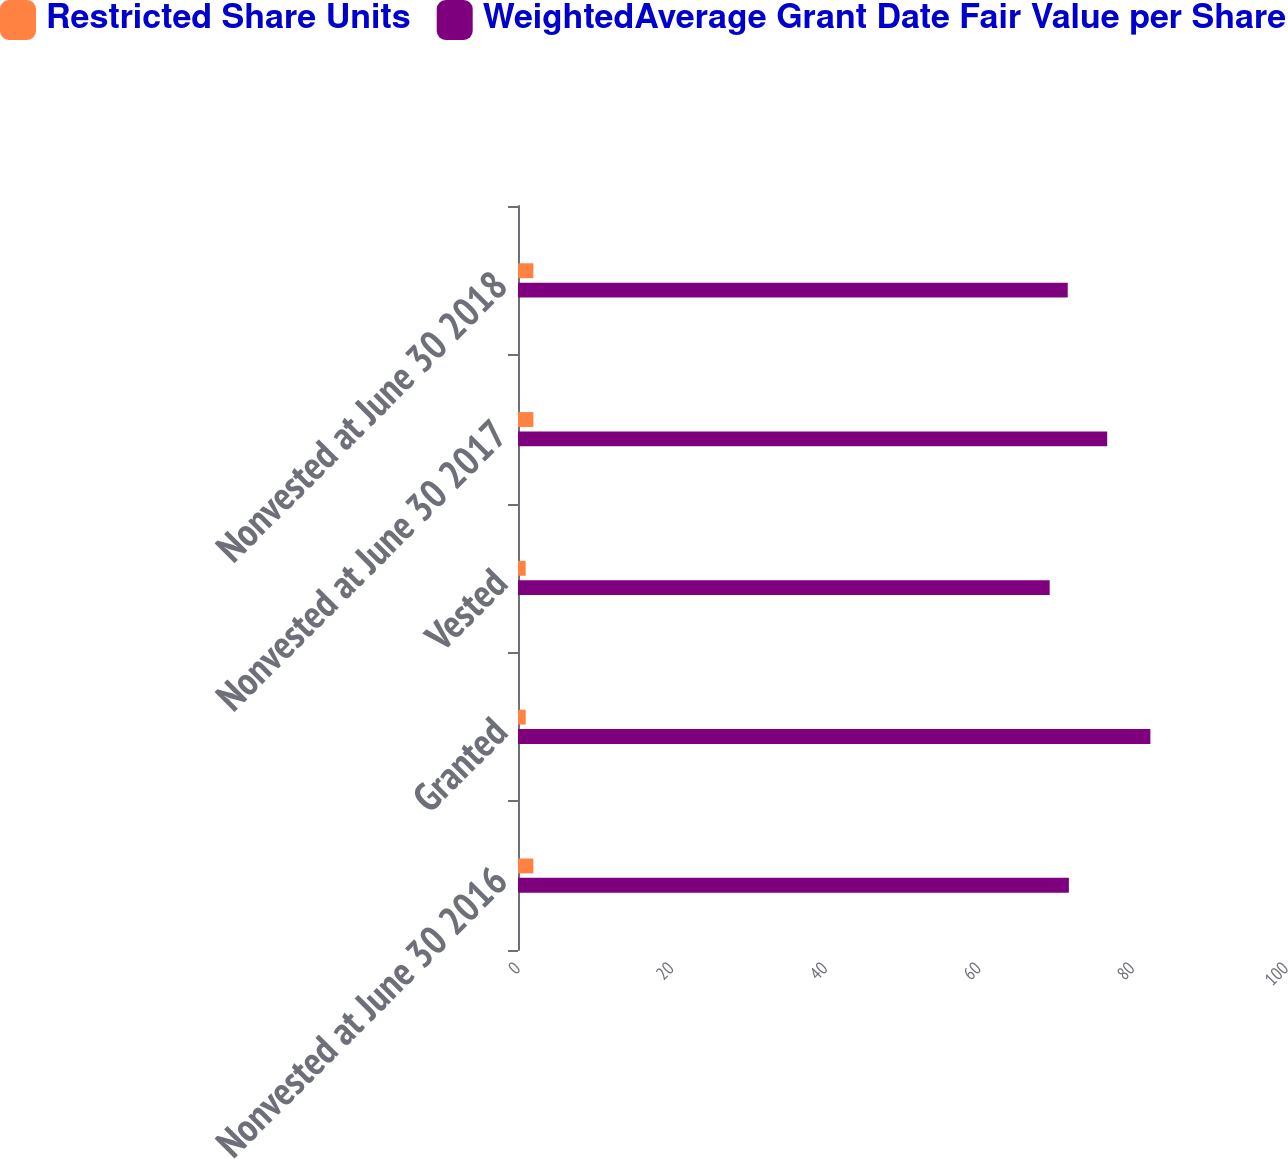Convert chart to OTSL. <chart><loc_0><loc_0><loc_500><loc_500><stacked_bar_chart><ecel><fcel>Nonvested at June 30 2016<fcel>Granted<fcel>Vested<fcel>Nonvested at June 30 2017<fcel>Nonvested at June 30 2018<nl><fcel>Restricted Share Units<fcel>2<fcel>1<fcel>1<fcel>2<fcel>2<nl><fcel>WeightedAverage Grant Date Fair Value per Share<fcel>71.73<fcel>82.34<fcel>69.23<fcel>76.72<fcel>71.58<nl></chart> 